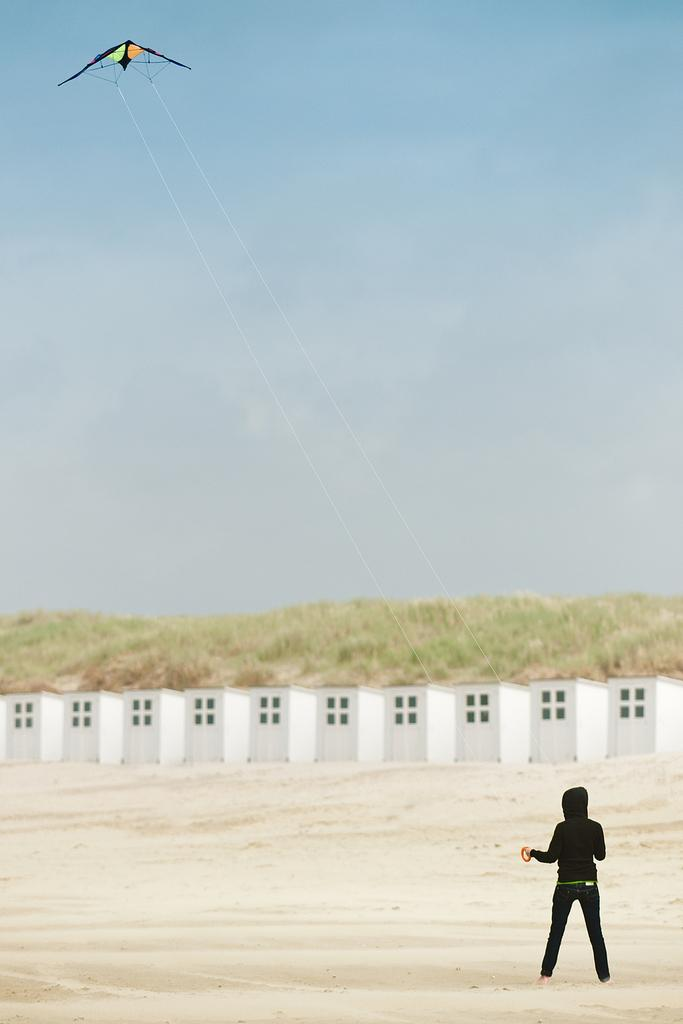What is the person in the image doing? The person is flying a kite. Where is the person standing? The person is standing on the sand. What can be seen in the background of the image? There is a constructed fence in the background. What type of vegetation is present in the image? Grass is present in the image. What is visible above the person and the fence? The sky is visible in the image. What type of cushion is being used to support the kite in the image? There is no cushion present in the image; the person is flying the kite without any visible support. Which direction is the person facing in the image? The image does not provide information about the person's facing direction, only that they are flying a kite. 